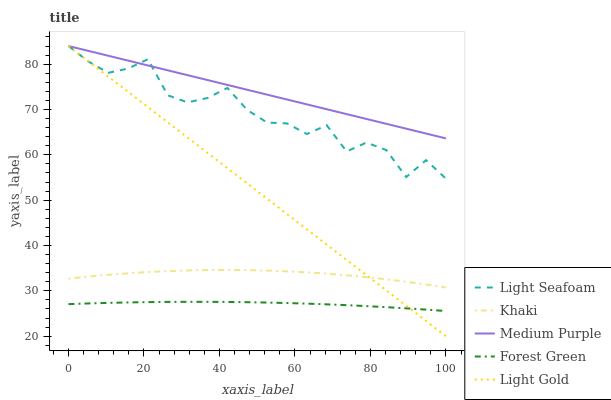Does Forest Green have the minimum area under the curve?
Answer yes or no. Yes. Does Medium Purple have the maximum area under the curve?
Answer yes or no. Yes. Does Light Seafoam have the minimum area under the curve?
Answer yes or no. No. Does Light Seafoam have the maximum area under the curve?
Answer yes or no. No. Is Medium Purple the smoothest?
Answer yes or no. Yes. Is Light Seafoam the roughest?
Answer yes or no. Yes. Is Forest Green the smoothest?
Answer yes or no. No. Is Forest Green the roughest?
Answer yes or no. No. Does Forest Green have the lowest value?
Answer yes or no. No. Does Forest Green have the highest value?
Answer yes or no. No. Is Forest Green less than Medium Purple?
Answer yes or no. Yes. Is Light Seafoam greater than Khaki?
Answer yes or no. Yes. Does Forest Green intersect Medium Purple?
Answer yes or no. No. 